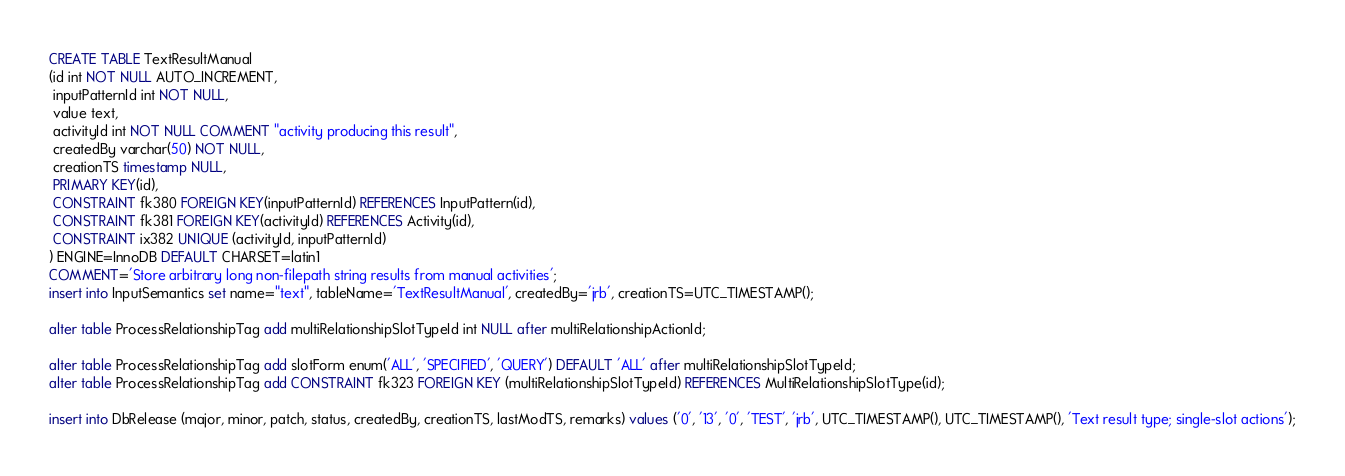<code> <loc_0><loc_0><loc_500><loc_500><_SQL_>CREATE TABLE TextResultManual
(id int NOT NULL AUTO_INCREMENT,
 inputPatternId int NOT NULL,
 value text,
 activityId int NOT NULL COMMENT "activity producing this result",
 createdBy varchar(50) NOT NULL,
 creationTS timestamp NULL,
 PRIMARY KEY(id),
 CONSTRAINT fk380 FOREIGN KEY(inputPatternId) REFERENCES InputPattern(id),
 CONSTRAINT fk381 FOREIGN KEY(activityId) REFERENCES Activity(id),
 CONSTRAINT ix382 UNIQUE (activityId, inputPatternId)
) ENGINE=InnoDB DEFAULT CHARSET=latin1
COMMENT='Store arbitrary long non-filepath string results from manual activities';
insert into InputSemantics set name="text", tableName='TextResultManual', createdBy='jrb', creationTS=UTC_TIMESTAMP();

alter table ProcessRelationshipTag add multiRelationshipSlotTypeId int NULL after multiRelationshipActionId;

alter table ProcessRelationshipTag add slotForm enum('ALL', 'SPECIFIED', 'QUERY') DEFAULT 'ALL' after multiRelationshipSlotTypeId;
alter table ProcessRelationshipTag add CONSTRAINT fk323 FOREIGN KEY (multiRelationshipSlotTypeId) REFERENCES MultiRelationshipSlotType(id);

insert into DbRelease (major, minor, patch, status, createdBy, creationTS, lastModTS, remarks) values ('0', '13', '0', 'TEST', 'jrb', UTC_TIMESTAMP(), UTC_TIMESTAMP(), 'Text result type; single-slot actions');


</code> 